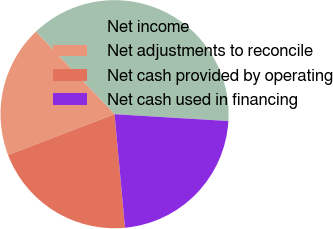Convert chart. <chart><loc_0><loc_0><loc_500><loc_500><pie_chart><fcel>Net income<fcel>Net adjustments to reconcile<fcel>Net cash provided by operating<fcel>Net cash used in financing<nl><fcel>38.07%<fcel>18.71%<fcel>20.64%<fcel>22.58%<nl></chart> 